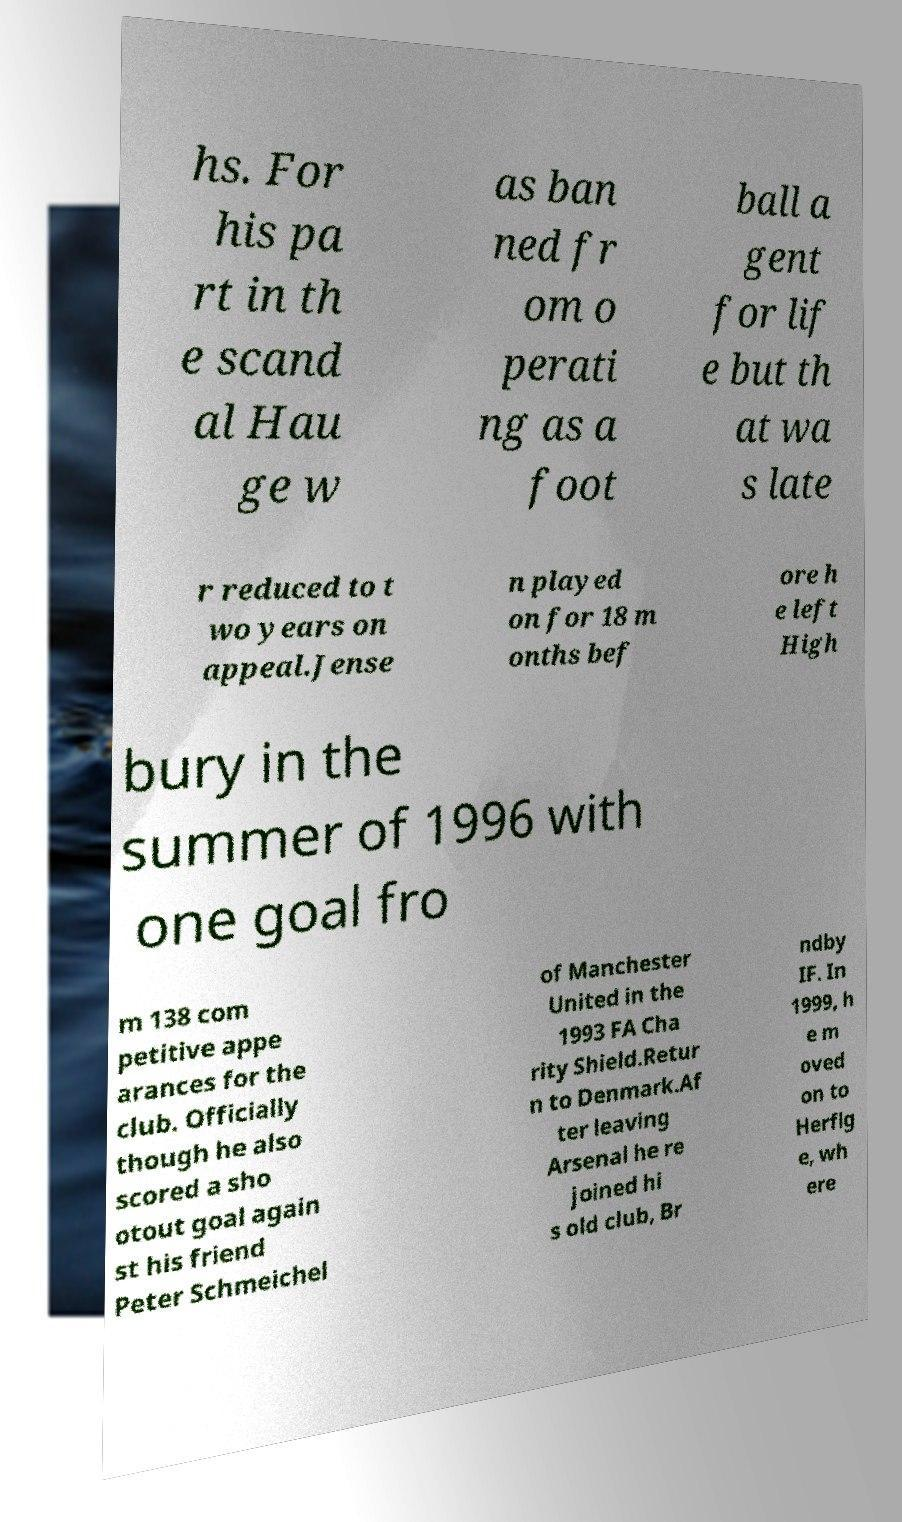Can you read and provide the text displayed in the image?This photo seems to have some interesting text. Can you extract and type it out for me? hs. For his pa rt in th e scand al Hau ge w as ban ned fr om o perati ng as a foot ball a gent for lif e but th at wa s late r reduced to t wo years on appeal.Jense n played on for 18 m onths bef ore h e left High bury in the summer of 1996 with one goal fro m 138 com petitive appe arances for the club. Officially though he also scored a sho otout goal again st his friend Peter Schmeichel of Manchester United in the 1993 FA Cha rity Shield.Retur n to Denmark.Af ter leaving Arsenal he re joined hi s old club, Br ndby IF. In 1999, h e m oved on to Herflg e, wh ere 